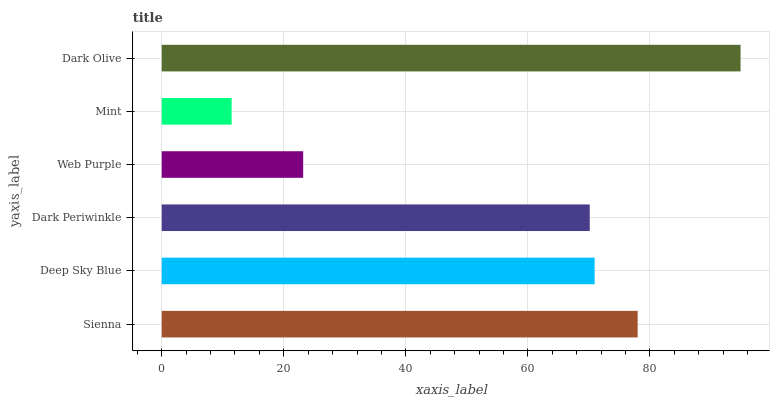Is Mint the minimum?
Answer yes or no. Yes. Is Dark Olive the maximum?
Answer yes or no. Yes. Is Deep Sky Blue the minimum?
Answer yes or no. No. Is Deep Sky Blue the maximum?
Answer yes or no. No. Is Sienna greater than Deep Sky Blue?
Answer yes or no. Yes. Is Deep Sky Blue less than Sienna?
Answer yes or no. Yes. Is Deep Sky Blue greater than Sienna?
Answer yes or no. No. Is Sienna less than Deep Sky Blue?
Answer yes or no. No. Is Deep Sky Blue the high median?
Answer yes or no. Yes. Is Dark Periwinkle the low median?
Answer yes or no. Yes. Is Dark Olive the high median?
Answer yes or no. No. Is Sienna the low median?
Answer yes or no. No. 